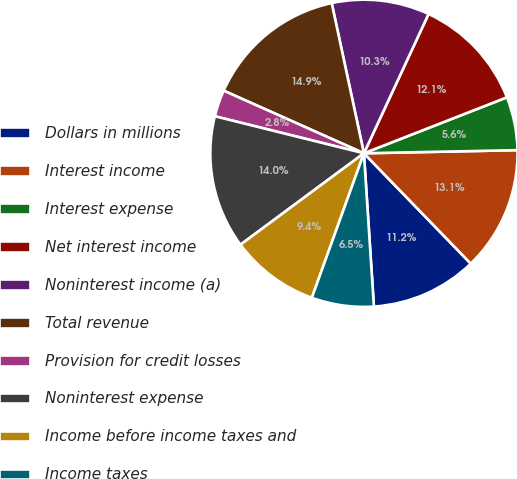Convert chart to OTSL. <chart><loc_0><loc_0><loc_500><loc_500><pie_chart><fcel>Dollars in millions<fcel>Interest income<fcel>Interest expense<fcel>Net interest income<fcel>Noninterest income (a)<fcel>Total revenue<fcel>Provision for credit losses<fcel>Noninterest expense<fcel>Income before income taxes and<fcel>Income taxes<nl><fcel>11.21%<fcel>13.08%<fcel>5.61%<fcel>12.15%<fcel>10.28%<fcel>14.95%<fcel>2.81%<fcel>14.02%<fcel>9.35%<fcel>6.54%<nl></chart> 